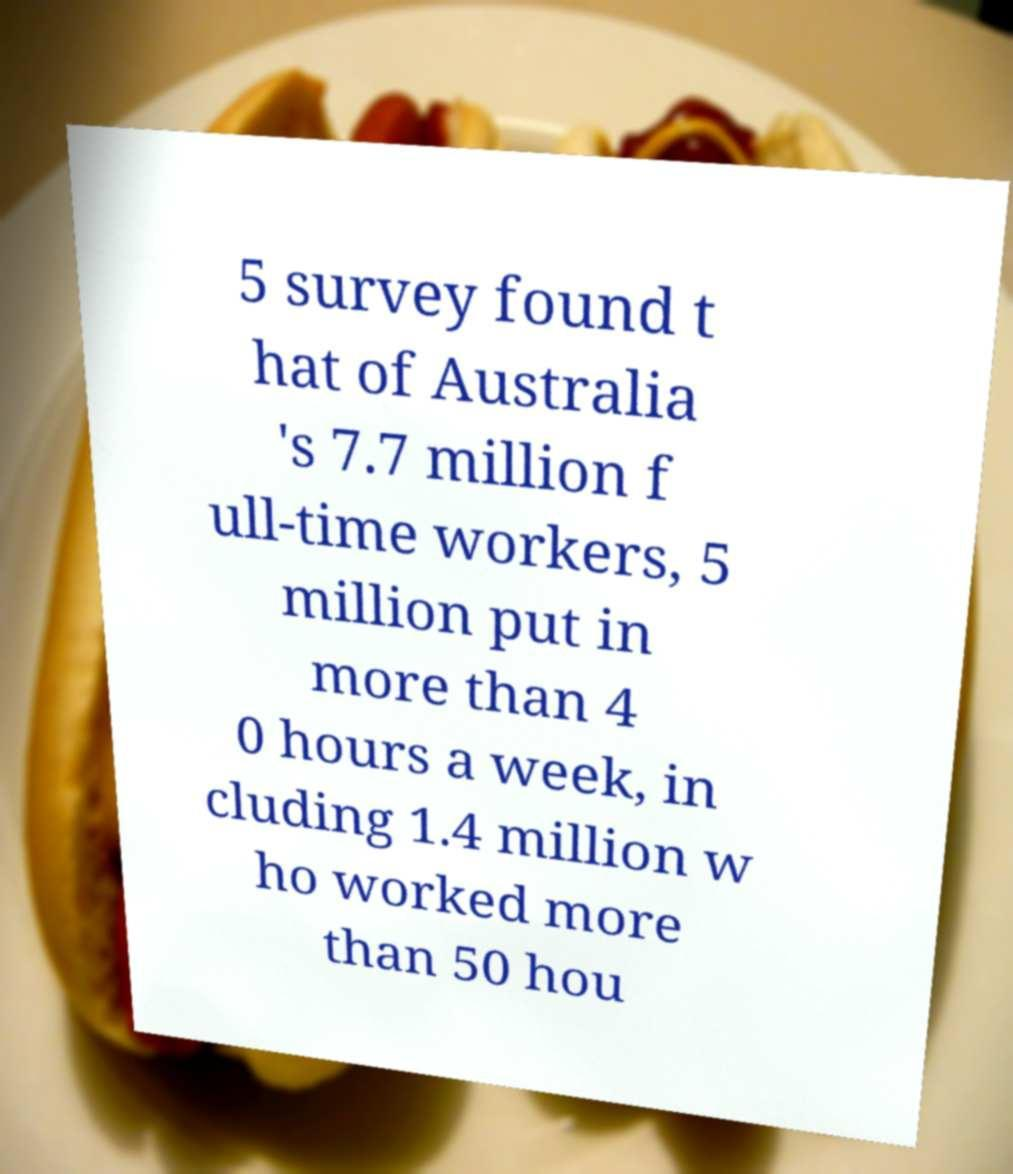Can you accurately transcribe the text from the provided image for me? 5 survey found t hat of Australia 's 7.7 million f ull-time workers, 5 million put in more than 4 0 hours a week, in cluding 1.4 million w ho worked more than 50 hou 